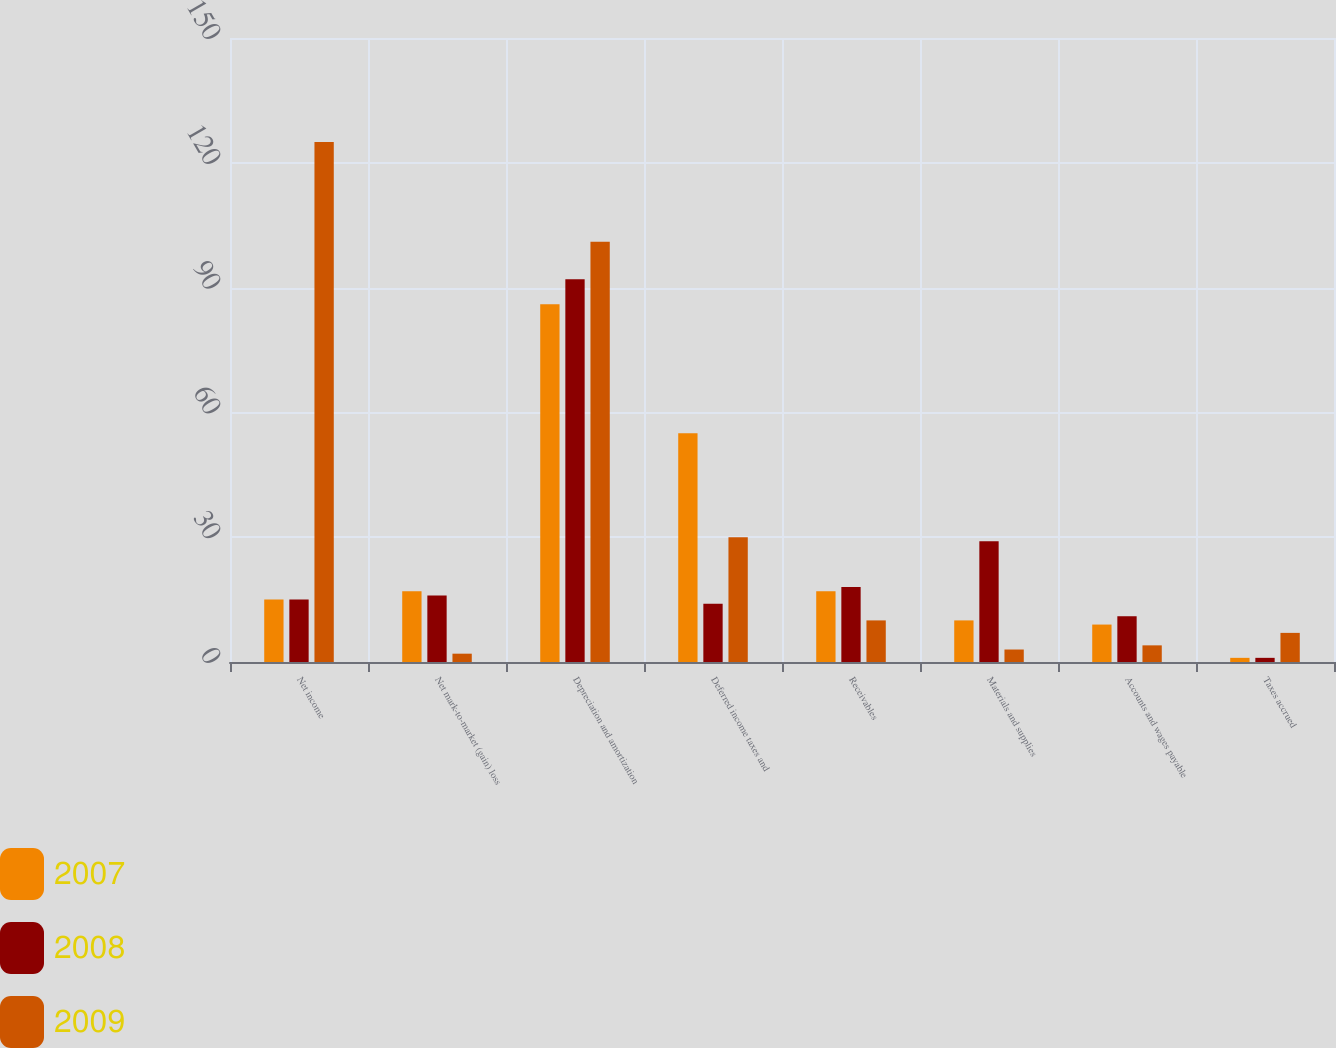Convert chart to OTSL. <chart><loc_0><loc_0><loc_500><loc_500><stacked_bar_chart><ecel><fcel>Net income<fcel>Net mark-to-market (gain) loss<fcel>Depreciation and amortization<fcel>Deferred income taxes and<fcel>Receivables<fcel>Materials and supplies<fcel>Accounts and wages payable<fcel>Taxes accrued<nl><fcel>2007<fcel>15<fcel>17<fcel>86<fcel>55<fcel>17<fcel>10<fcel>9<fcel>1<nl><fcel>2008<fcel>15<fcel>16<fcel>92<fcel>14<fcel>18<fcel>29<fcel>11<fcel>1<nl><fcel>2009<fcel>125<fcel>2<fcel>101<fcel>30<fcel>10<fcel>3<fcel>4<fcel>7<nl></chart> 